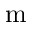<formula> <loc_0><loc_0><loc_500><loc_500>m</formula> 